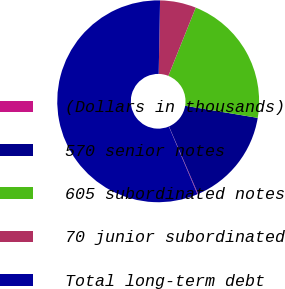Convert chart. <chart><loc_0><loc_0><loc_500><loc_500><pie_chart><fcel>(Dollars in thousands)<fcel>570 senior notes<fcel>605 subordinated notes<fcel>70 junior subordinated<fcel>Total long-term debt<nl><fcel>0.11%<fcel>15.9%<fcel>21.56%<fcel>5.77%<fcel>56.66%<nl></chart> 